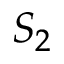Convert formula to latex. <formula><loc_0><loc_0><loc_500><loc_500>S _ { 2 }</formula> 